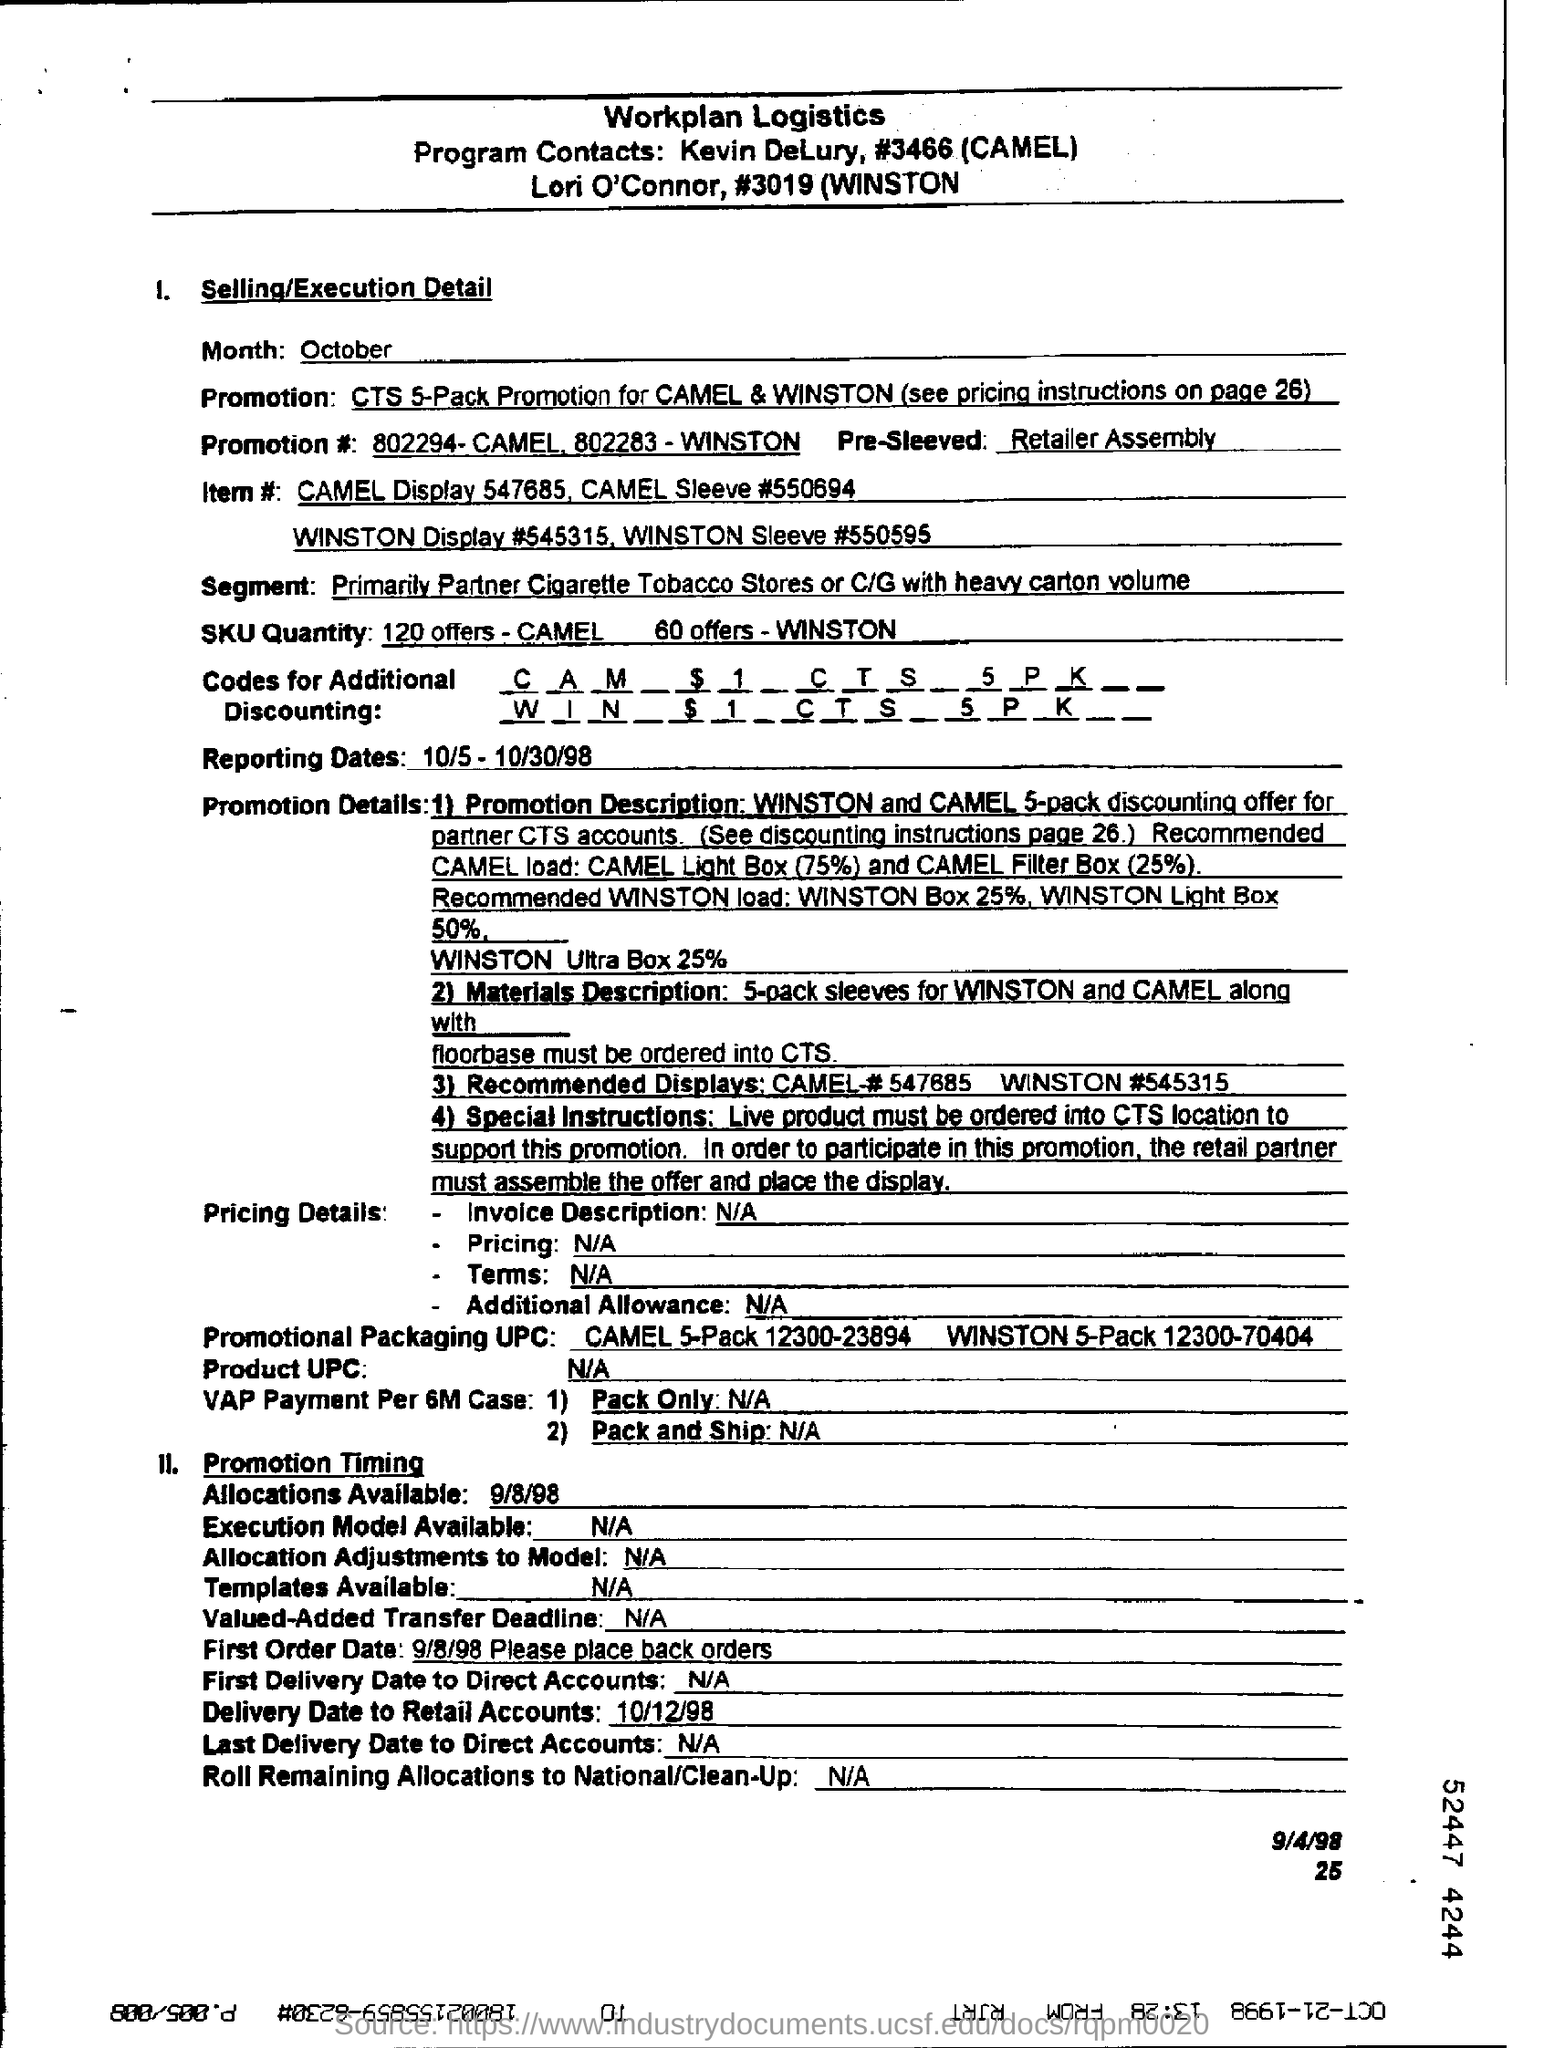What is written in the blank pre-sleeved?
Give a very brief answer. Retailer Assembly. What are the reporting dates?
Ensure brevity in your answer.  10/5- 10/30/98. What is the product UPC?
Provide a succinct answer. N/A. What is the delivery date to retail accounts?
Provide a succinct answer. 10/12/98. 